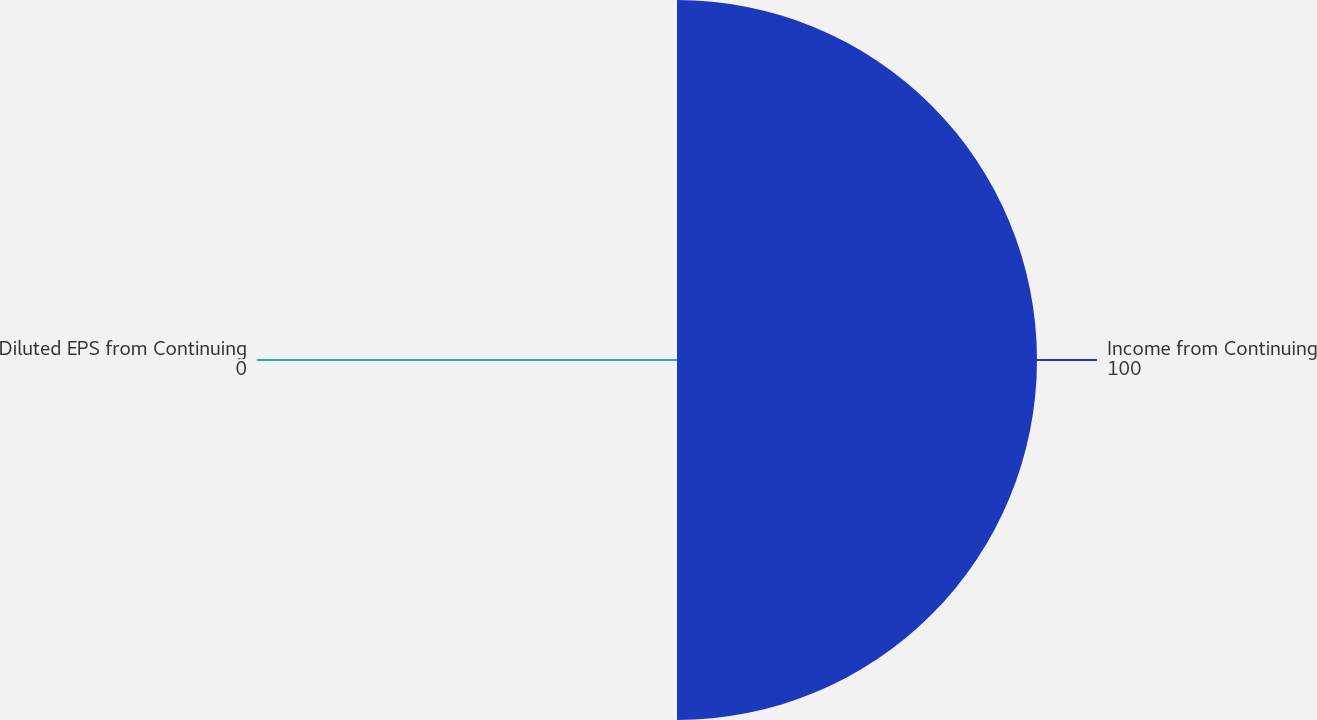<chart> <loc_0><loc_0><loc_500><loc_500><pie_chart><fcel>Income from Continuing<fcel>Diluted EPS from Continuing<nl><fcel>100.0%<fcel>0.0%<nl></chart> 